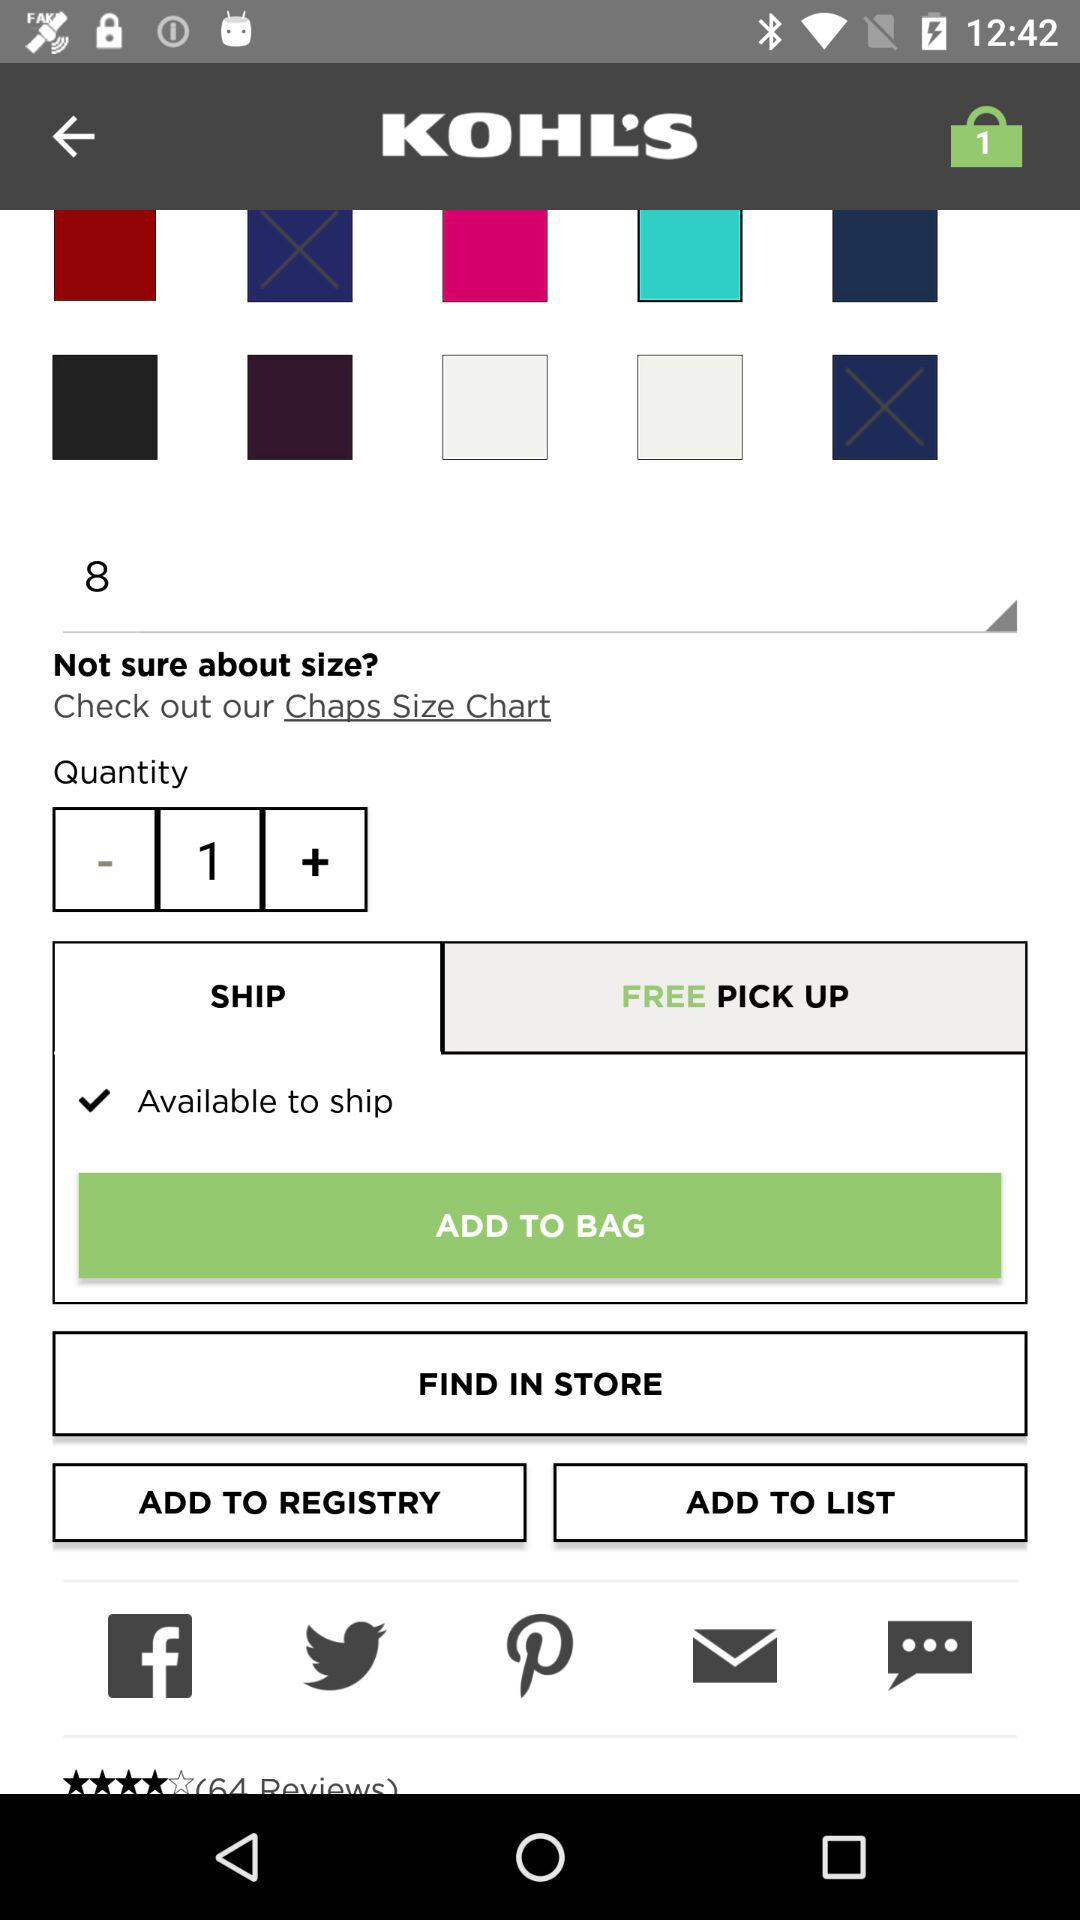What is the selected quantity? The selected quantity is 1. 